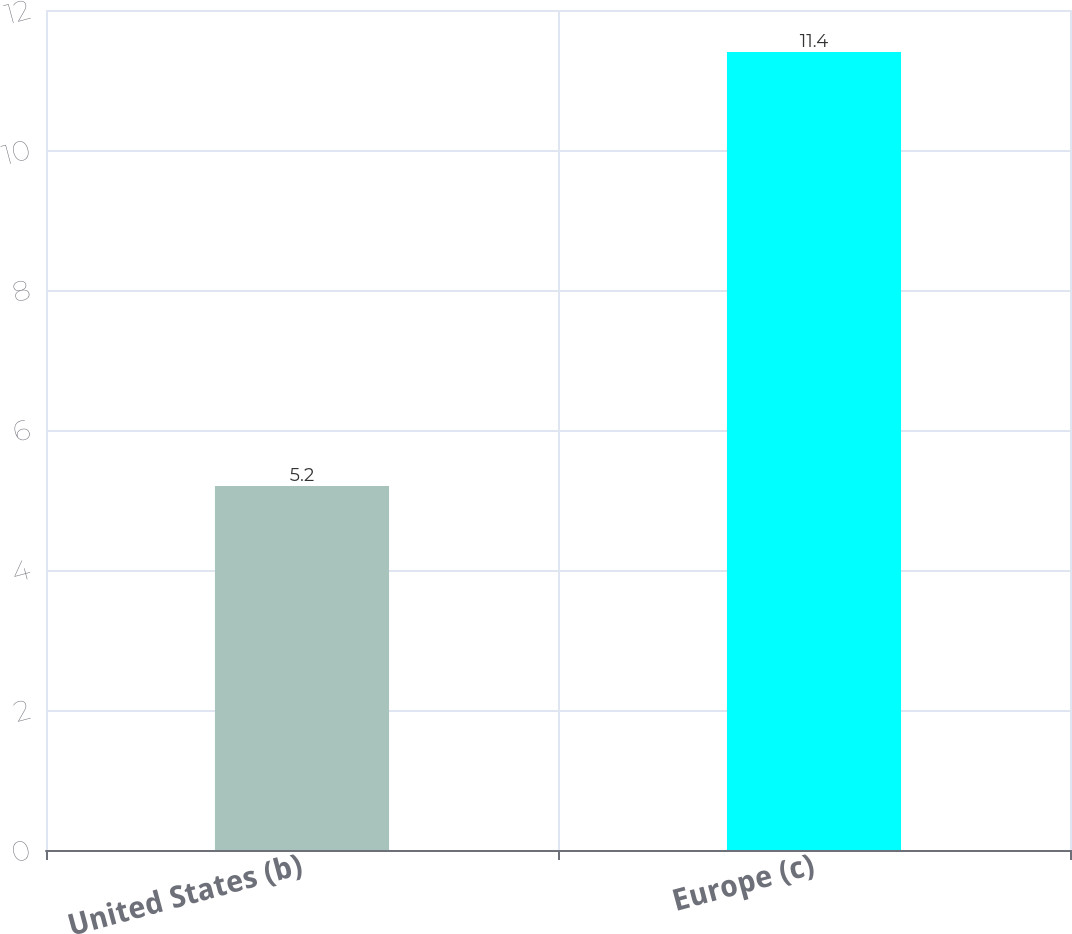Convert chart. <chart><loc_0><loc_0><loc_500><loc_500><bar_chart><fcel>United States (b)<fcel>Europe (c)<nl><fcel>5.2<fcel>11.4<nl></chart> 